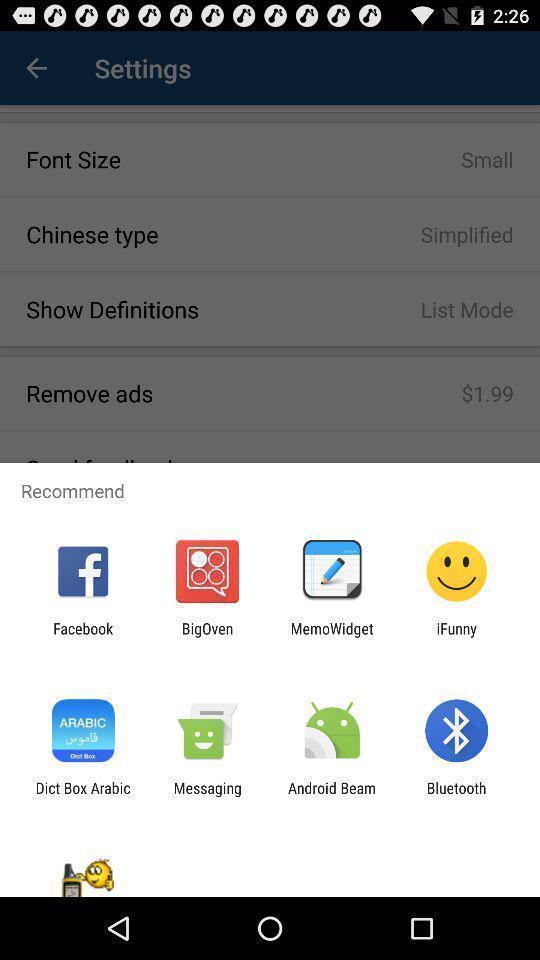Describe the visual elements of this screenshot. Recommended app options on the dictionary app. 